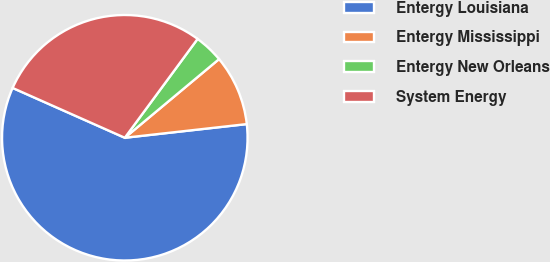<chart> <loc_0><loc_0><loc_500><loc_500><pie_chart><fcel>Entergy Louisiana<fcel>Entergy Mississippi<fcel>Entergy New Orleans<fcel>System Energy<nl><fcel>58.43%<fcel>9.29%<fcel>3.83%<fcel>28.45%<nl></chart> 